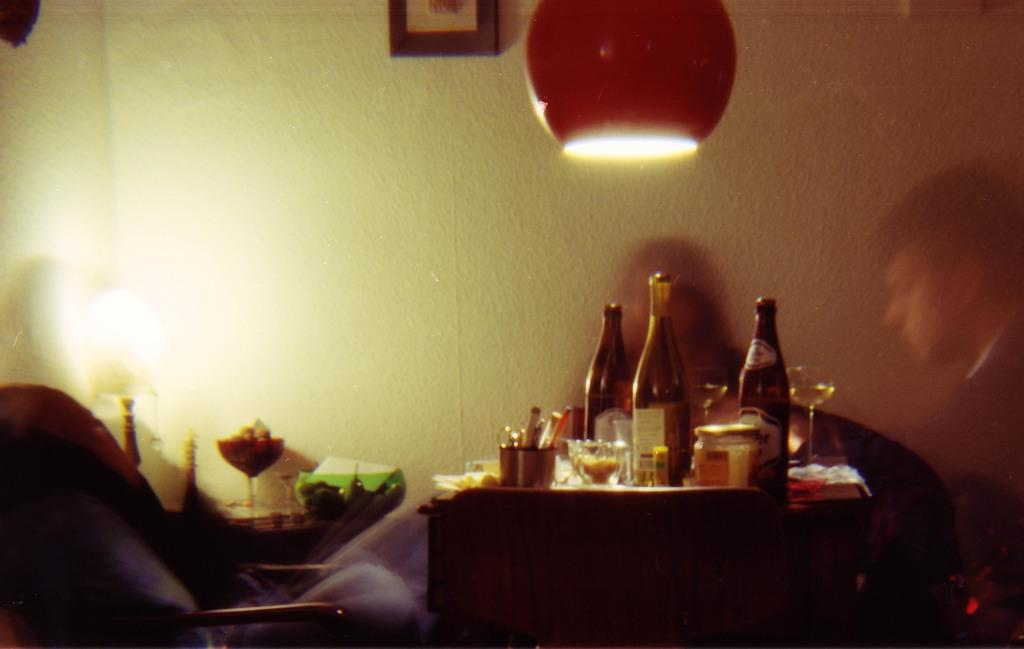What objects are on the table in the image? There are bottles and jars on a table, along with other unspecified things. What can be seen on the wall in the image? There is a photo on the wall. What type of lighting is present in the image? There is a lamp in the image. What is on another table in the image? There is a bowl on another table, along with an unspecified object. Can you describe the people in the image? People's reflections are visible in the image. How many dimes are visible on the table in the image? There are no dimes visible on the table in the image. What type of motion is occurring in the image? There is no motion occurring in the image; it appears to be a still scene. 